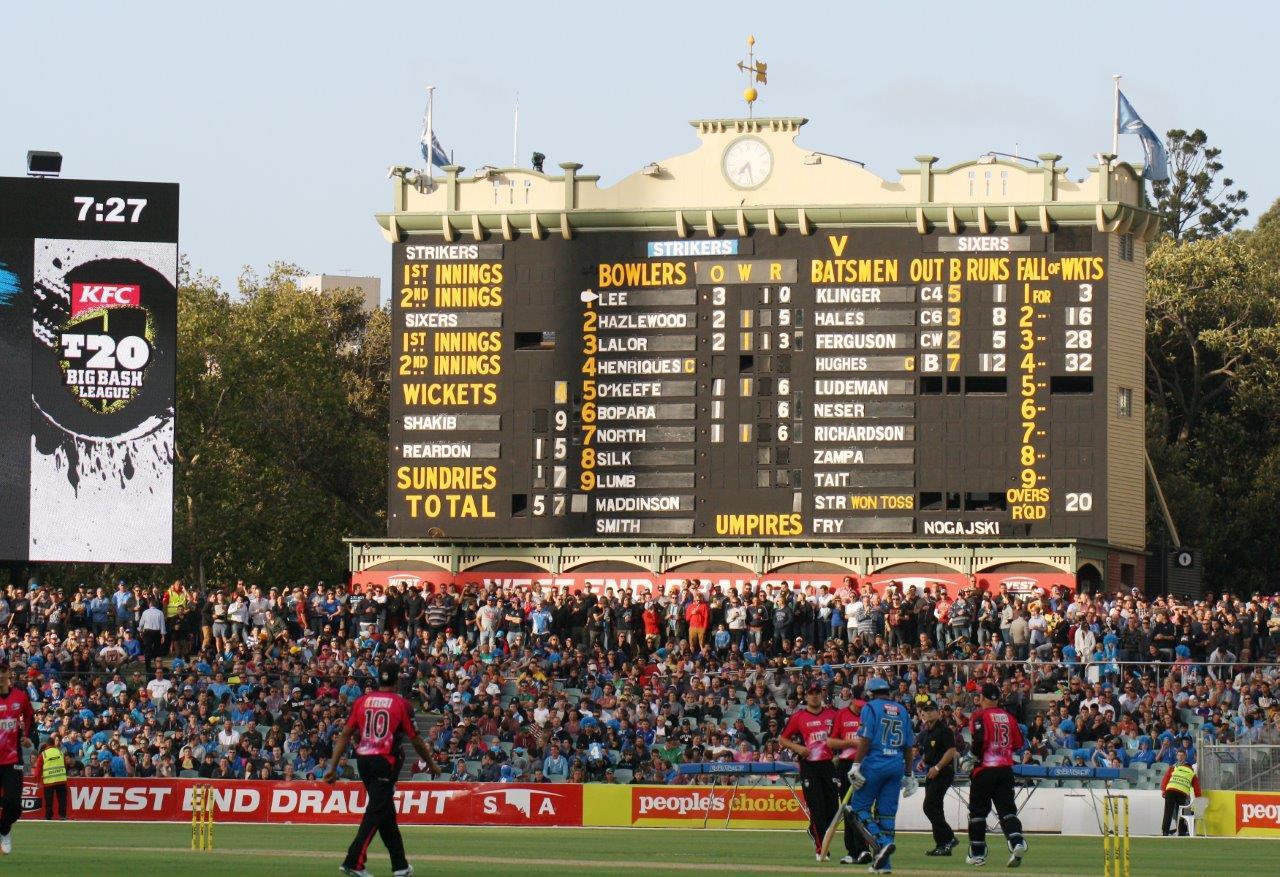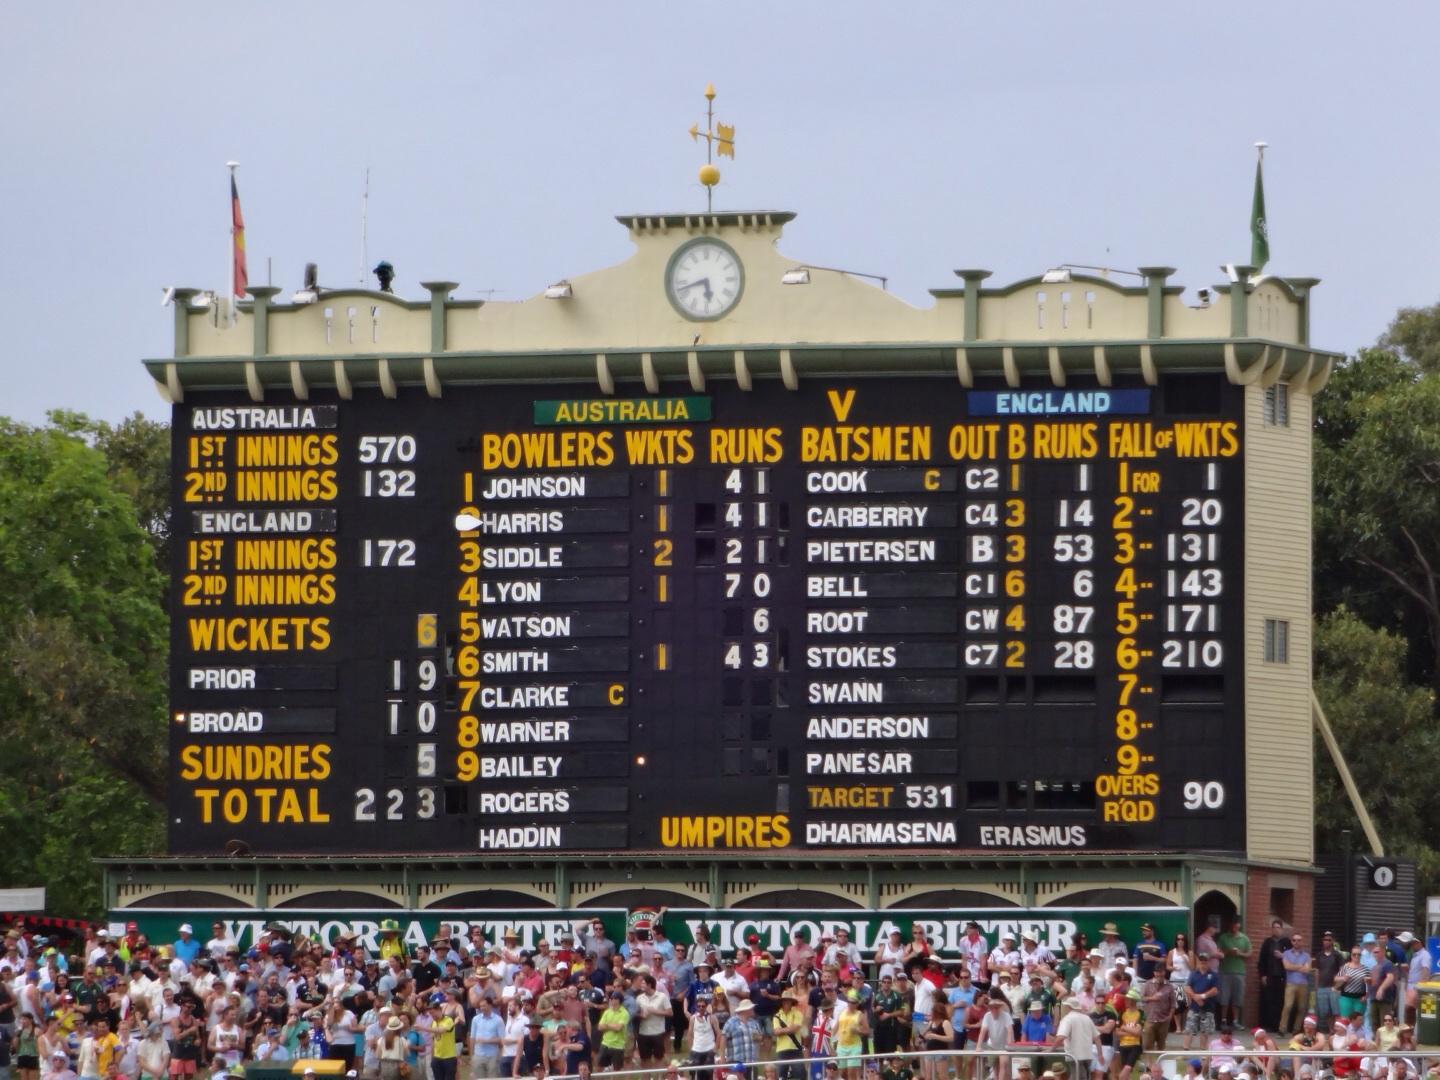The first image is the image on the left, the second image is the image on the right. Examine the images to the left and right. Is the description "A blue advertisement sits beneath the scoreboard in the image on the left." accurate? Answer yes or no. No. The first image is the image on the left, the second image is the image on the right. For the images shown, is this caption "Each image features a scoreboard with a clock centered above it, and one image shows a horizontal blue banner hanging under and in front of the scoreboard." true? Answer yes or no. No. 